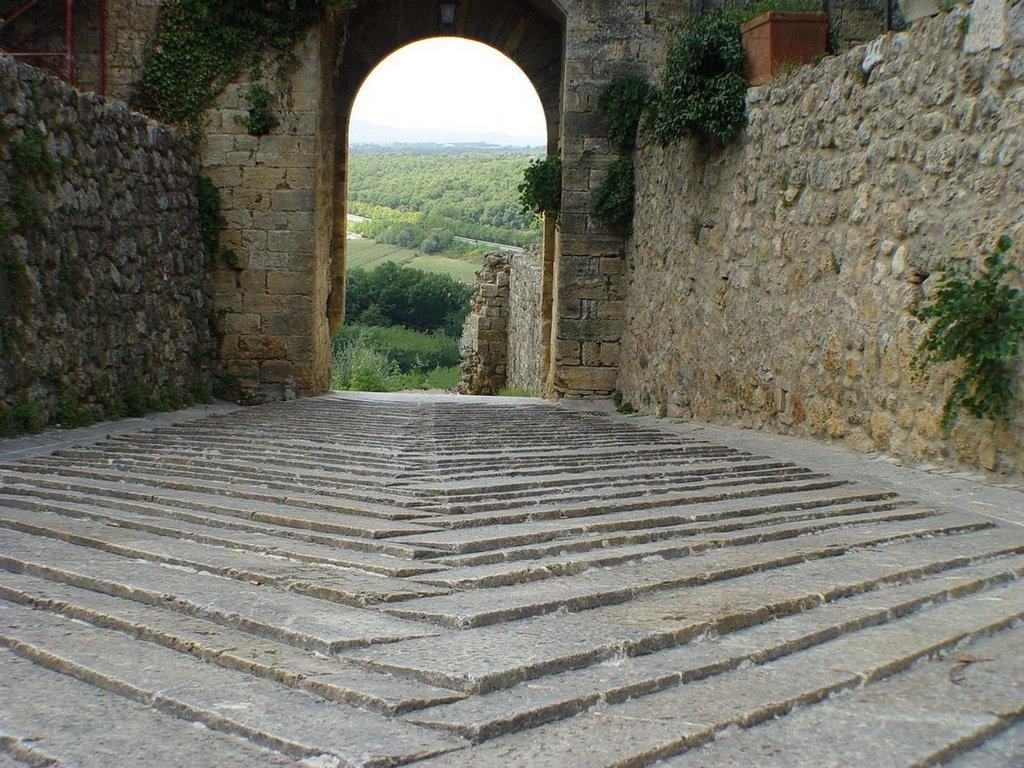What type of surface is visible in the image? The image contains a floor. What else can be seen in the image besides the floor? The image contains a wall, objects on the wall, an arch, the ground with grass, trees, plants, and the sky. Can you describe the objects on the wall? Unfortunately, the facts provided do not give specific details about the objects on the wall. What type of vegetation is present in the image? Trees and plants are visible in the image. What holiday is being celebrated in the image? There is no indication of a holiday being celebrated in the image. How does the anger of the trees manifest in the image? There is no anger present in the image, as it features trees and plants. 